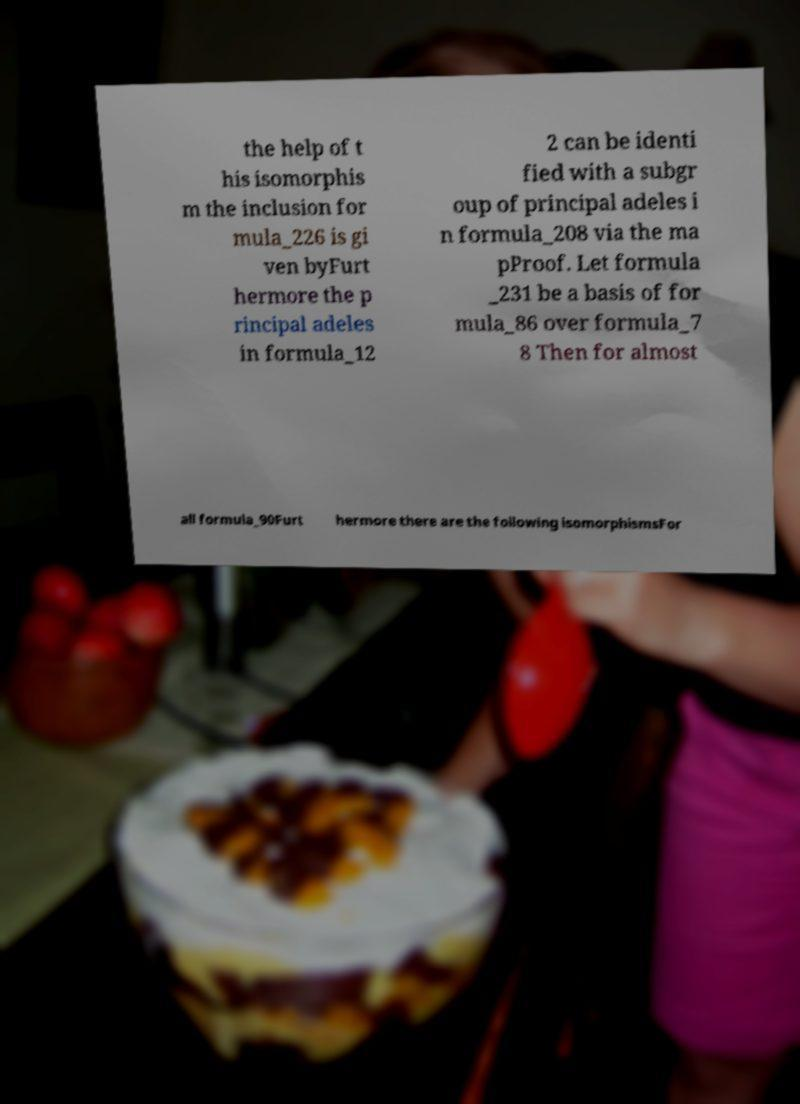Could you assist in decoding the text presented in this image and type it out clearly? the help of t his isomorphis m the inclusion for mula_226 is gi ven byFurt hermore the p rincipal adeles in formula_12 2 can be identi fied with a subgr oup of principal adeles i n formula_208 via the ma pProof. Let formula _231 be a basis of for mula_86 over formula_7 8 Then for almost all formula_90Furt hermore there are the following isomorphismsFor 